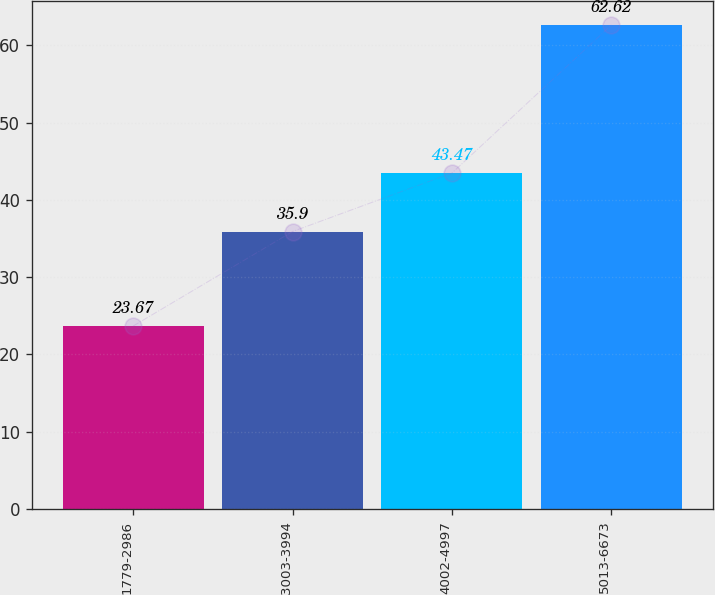<chart> <loc_0><loc_0><loc_500><loc_500><bar_chart><fcel>1779-2986<fcel>3003-3994<fcel>4002-4997<fcel>5013-6673<nl><fcel>23.67<fcel>35.9<fcel>43.47<fcel>62.62<nl></chart> 